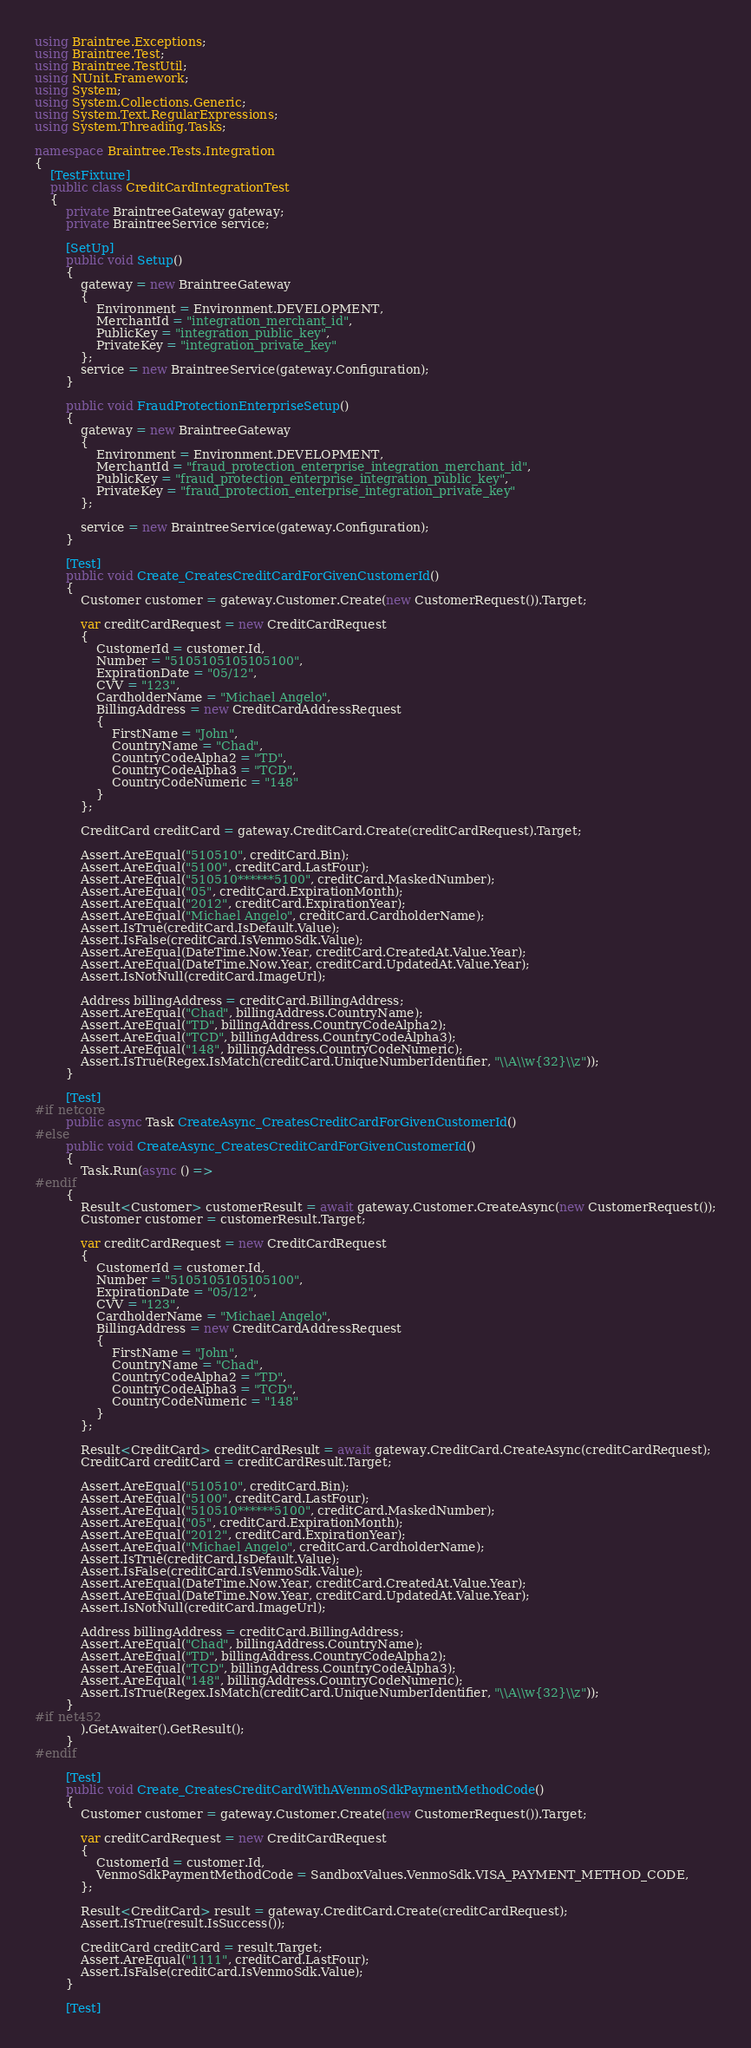<code> <loc_0><loc_0><loc_500><loc_500><_C#_>using Braintree.Exceptions;
using Braintree.Test;
using Braintree.TestUtil;
using NUnit.Framework;
using System;
using System.Collections.Generic;
using System.Text.RegularExpressions;
using System.Threading.Tasks;

namespace Braintree.Tests.Integration
{
    [TestFixture]
    public class CreditCardIntegrationTest
    {
        private BraintreeGateway gateway;
        private BraintreeService service;

        [SetUp]
        public void Setup()
        {
            gateway = new BraintreeGateway
            {
                Environment = Environment.DEVELOPMENT,
                MerchantId = "integration_merchant_id",
                PublicKey = "integration_public_key",
                PrivateKey = "integration_private_key"
            };
            service = new BraintreeService(gateway.Configuration);
        }

        public void FraudProtectionEnterpriseSetup()
        {
            gateway = new BraintreeGateway
            {
                Environment = Environment.DEVELOPMENT,
                MerchantId = "fraud_protection_enterprise_integration_merchant_id",
                PublicKey = "fraud_protection_enterprise_integration_public_key",
                PrivateKey = "fraud_protection_enterprise_integration_private_key"
            };

            service = new BraintreeService(gateway.Configuration);
        }

        [Test]
        public void Create_CreatesCreditCardForGivenCustomerId()
        {
            Customer customer = gateway.Customer.Create(new CustomerRequest()).Target;

            var creditCardRequest = new CreditCardRequest
            {
                CustomerId = customer.Id,
                Number = "5105105105105100",
                ExpirationDate = "05/12",
                CVV = "123",
                CardholderName = "Michael Angelo",
                BillingAddress = new CreditCardAddressRequest
                {
                    FirstName = "John",
                    CountryName = "Chad",
                    CountryCodeAlpha2 = "TD",
                    CountryCodeAlpha3 = "TCD",
                    CountryCodeNumeric = "148"
                }
            };

            CreditCard creditCard = gateway.CreditCard.Create(creditCardRequest).Target;

            Assert.AreEqual("510510", creditCard.Bin);
            Assert.AreEqual("5100", creditCard.LastFour);
            Assert.AreEqual("510510******5100", creditCard.MaskedNumber);
            Assert.AreEqual("05", creditCard.ExpirationMonth);
            Assert.AreEqual("2012", creditCard.ExpirationYear);
            Assert.AreEqual("Michael Angelo", creditCard.CardholderName);
            Assert.IsTrue(creditCard.IsDefault.Value);
            Assert.IsFalse(creditCard.IsVenmoSdk.Value);
            Assert.AreEqual(DateTime.Now.Year, creditCard.CreatedAt.Value.Year);
            Assert.AreEqual(DateTime.Now.Year, creditCard.UpdatedAt.Value.Year);
            Assert.IsNotNull(creditCard.ImageUrl);

            Address billingAddress = creditCard.BillingAddress;
            Assert.AreEqual("Chad", billingAddress.CountryName);
            Assert.AreEqual("TD", billingAddress.CountryCodeAlpha2);
            Assert.AreEqual("TCD", billingAddress.CountryCodeAlpha3);
            Assert.AreEqual("148", billingAddress.CountryCodeNumeric);
            Assert.IsTrue(Regex.IsMatch(creditCard.UniqueNumberIdentifier, "\\A\\w{32}\\z"));
        }

        [Test]
#if netcore
        public async Task CreateAsync_CreatesCreditCardForGivenCustomerId()
#else
        public void CreateAsync_CreatesCreditCardForGivenCustomerId()
        {
            Task.Run(async () =>
#endif
        {
            Result<Customer> customerResult = await gateway.Customer.CreateAsync(new CustomerRequest());
            Customer customer = customerResult.Target;

            var creditCardRequest = new CreditCardRequest
            {
                CustomerId = customer.Id,
                Number = "5105105105105100",
                ExpirationDate = "05/12",
                CVV = "123",
                CardholderName = "Michael Angelo",
                BillingAddress = new CreditCardAddressRequest
                {
                    FirstName = "John",
                    CountryName = "Chad",
                    CountryCodeAlpha2 = "TD",
                    CountryCodeAlpha3 = "TCD",
                    CountryCodeNumeric = "148"
                }
            };

            Result<CreditCard> creditCardResult = await gateway.CreditCard.CreateAsync(creditCardRequest);
            CreditCard creditCard = creditCardResult.Target;

            Assert.AreEqual("510510", creditCard.Bin);
            Assert.AreEqual("5100", creditCard.LastFour);
            Assert.AreEqual("510510******5100", creditCard.MaskedNumber);
            Assert.AreEqual("05", creditCard.ExpirationMonth);
            Assert.AreEqual("2012", creditCard.ExpirationYear);
            Assert.AreEqual("Michael Angelo", creditCard.CardholderName);
            Assert.IsTrue(creditCard.IsDefault.Value);
            Assert.IsFalse(creditCard.IsVenmoSdk.Value);
            Assert.AreEqual(DateTime.Now.Year, creditCard.CreatedAt.Value.Year);
            Assert.AreEqual(DateTime.Now.Year, creditCard.UpdatedAt.Value.Year);
            Assert.IsNotNull(creditCard.ImageUrl);

            Address billingAddress = creditCard.BillingAddress;
            Assert.AreEqual("Chad", billingAddress.CountryName);
            Assert.AreEqual("TD", billingAddress.CountryCodeAlpha2);
            Assert.AreEqual("TCD", billingAddress.CountryCodeAlpha3);
            Assert.AreEqual("148", billingAddress.CountryCodeNumeric);
            Assert.IsTrue(Regex.IsMatch(creditCard.UniqueNumberIdentifier, "\\A\\w{32}\\z"));
        }
#if net452
            ).GetAwaiter().GetResult();
        }
#endif

        [Test]
        public void Create_CreatesCreditCardWithAVenmoSdkPaymentMethodCode()
        {
            Customer customer = gateway.Customer.Create(new CustomerRequest()).Target;

            var creditCardRequest = new CreditCardRequest
            {
                CustomerId = customer.Id,
                VenmoSdkPaymentMethodCode = SandboxValues.VenmoSdk.VISA_PAYMENT_METHOD_CODE,
            };

            Result<CreditCard> result = gateway.CreditCard.Create(creditCardRequest);
            Assert.IsTrue(result.IsSuccess());

            CreditCard creditCard = result.Target;
            Assert.AreEqual("1111", creditCard.LastFour);
            Assert.IsFalse(creditCard.IsVenmoSdk.Value);
        }

        [Test]</code> 